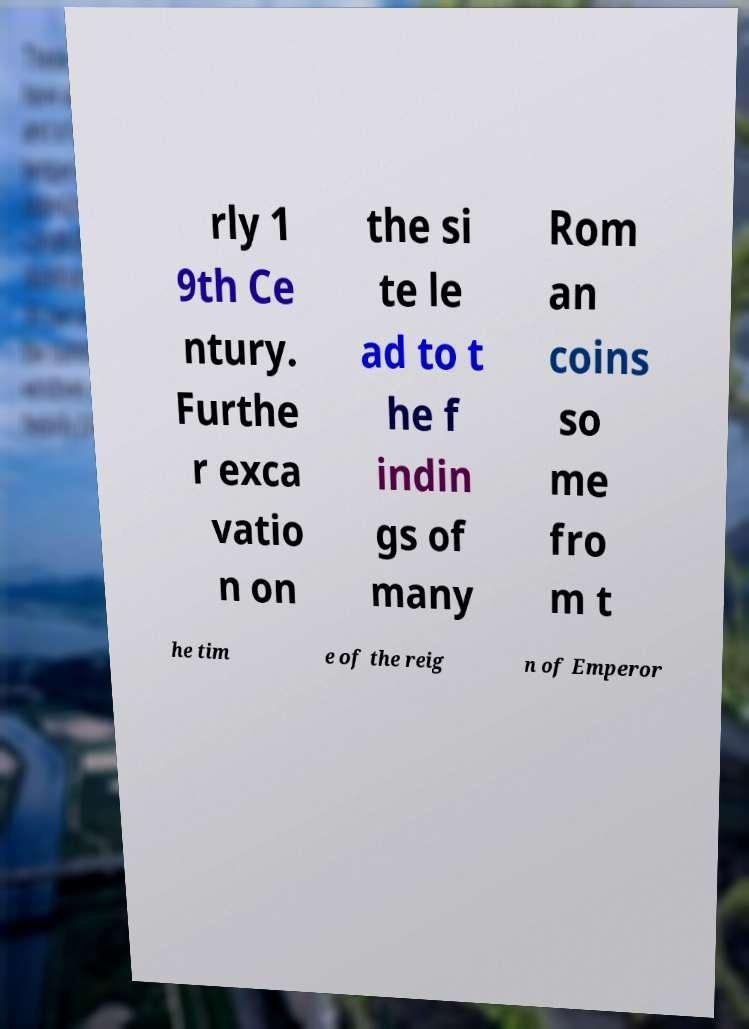Please read and relay the text visible in this image. What does it say? rly 1 9th Ce ntury. Furthe r exca vatio n on the si te le ad to t he f indin gs of many Rom an coins so me fro m t he tim e of the reig n of Emperor 